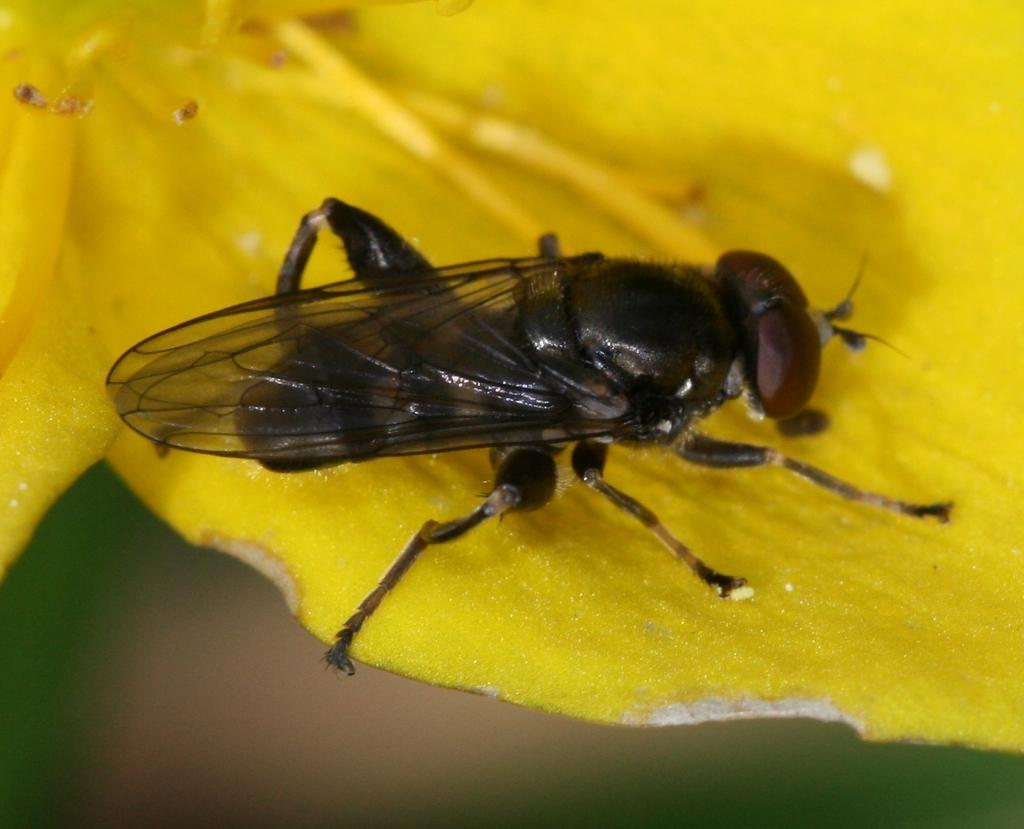What is present on the flower in the image? There is an insect on the flower in the image. Can you describe the insect's location on the flower? The insect is on the flower. What can be observed about the background of the image? The background of the image is blurry. What type of health advice can be seen in the image? There is no health advice present in the image; it features an insect on a flower with a blurry background. What type of blade is being used by the insect in the image? There is no blade present in the image; it features an insect on a flower with a blurry background. 